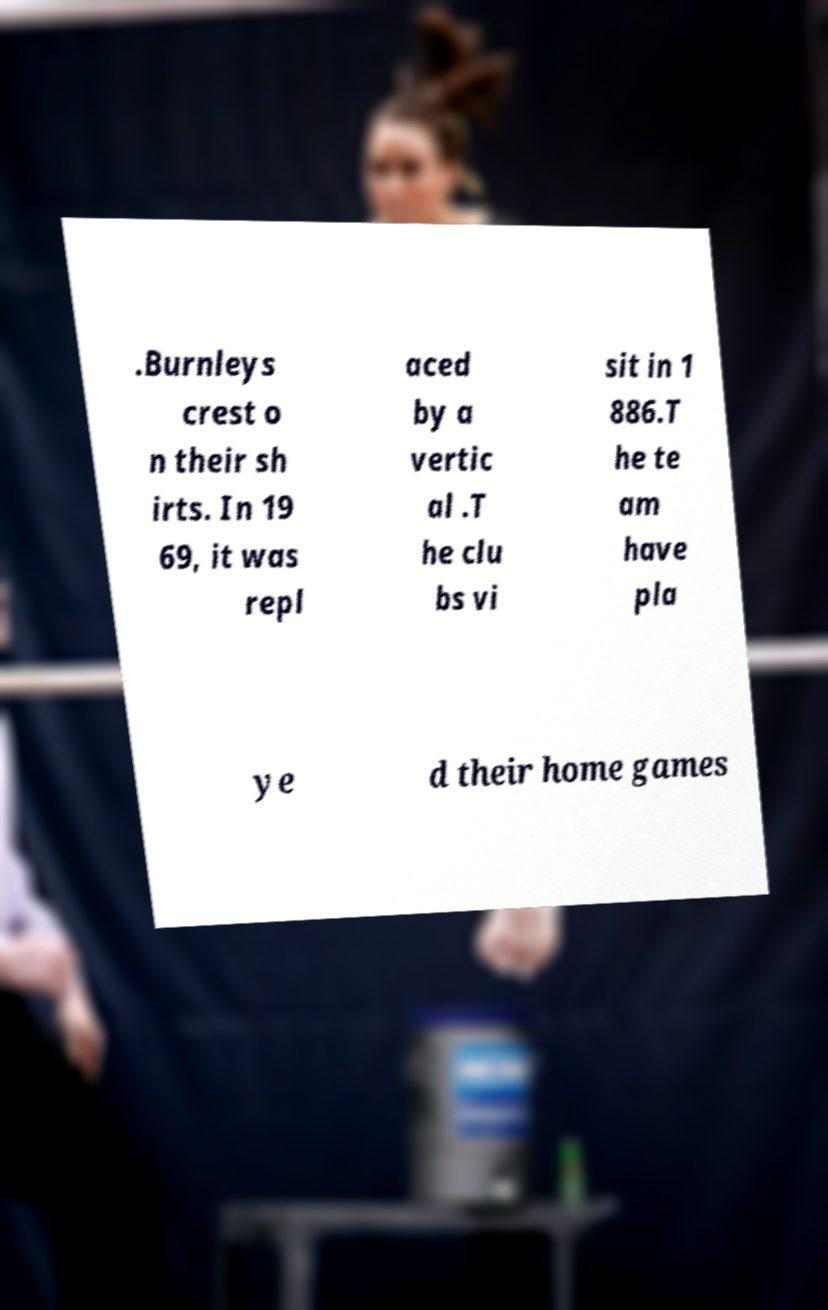Could you extract and type out the text from this image? .Burnleys crest o n their sh irts. In 19 69, it was repl aced by a vertic al .T he clu bs vi sit in 1 886.T he te am have pla ye d their home games 